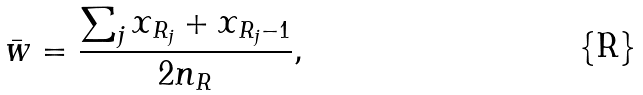<formula> <loc_0><loc_0><loc_500><loc_500>\bar { w } = \frac { \sum _ { j } x _ { R _ { j } } + x _ { R _ { j } - 1 } } { 2 n _ { R } } ,</formula> 